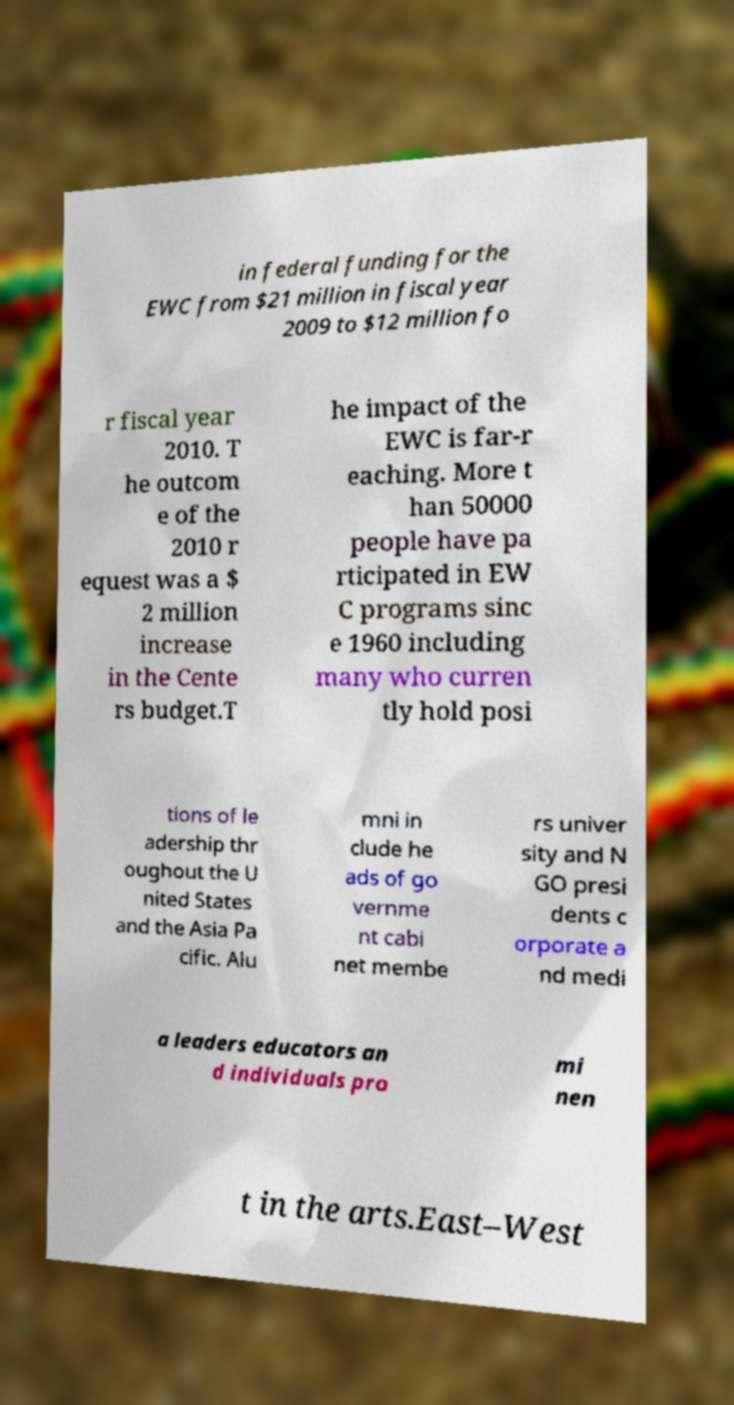Please read and relay the text visible in this image. What does it say? in federal funding for the EWC from $21 million in fiscal year 2009 to $12 million fo r fiscal year 2010. T he outcom e of the 2010 r equest was a $ 2 million increase in the Cente rs budget.T he impact of the EWC is far-r eaching. More t han 50000 people have pa rticipated in EW C programs sinc e 1960 including many who curren tly hold posi tions of le adership thr oughout the U nited States and the Asia Pa cific. Alu mni in clude he ads of go vernme nt cabi net membe rs univer sity and N GO presi dents c orporate a nd medi a leaders educators an d individuals pro mi nen t in the arts.East–West 